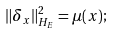Convert formula to latex. <formula><loc_0><loc_0><loc_500><loc_500>\| \delta _ { x } \| _ { H _ { E } } ^ { 2 } = \mu ( x ) ;</formula> 